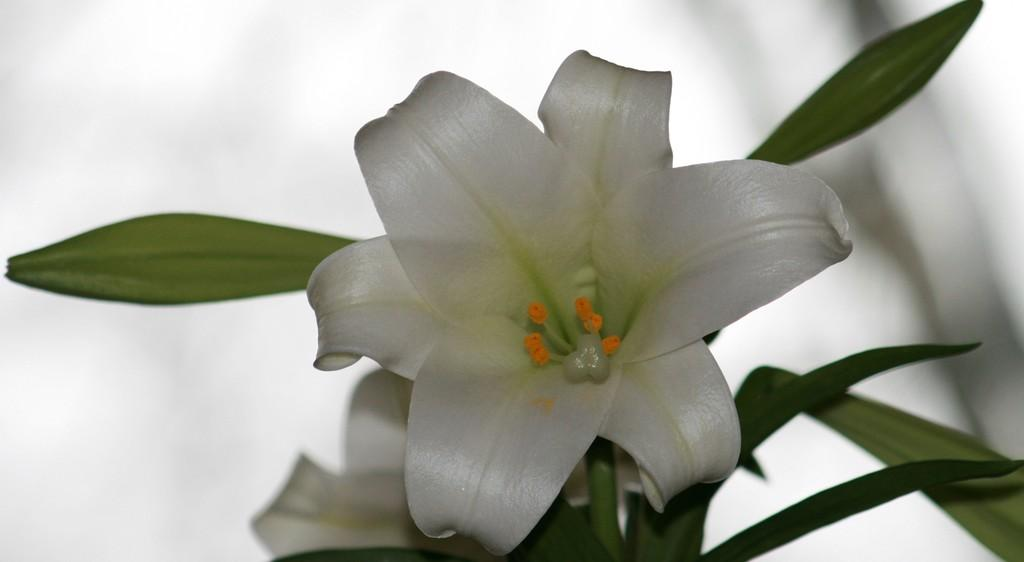What type of flower is in the image? There is a white lily in the image. What else can be seen in the image besides the flower? There are leaves in the image. How would you describe the background of the image? The background of the image is blurred. Can you see a zebra wearing a ring in the image? No, there is no zebra or ring present in the image. 